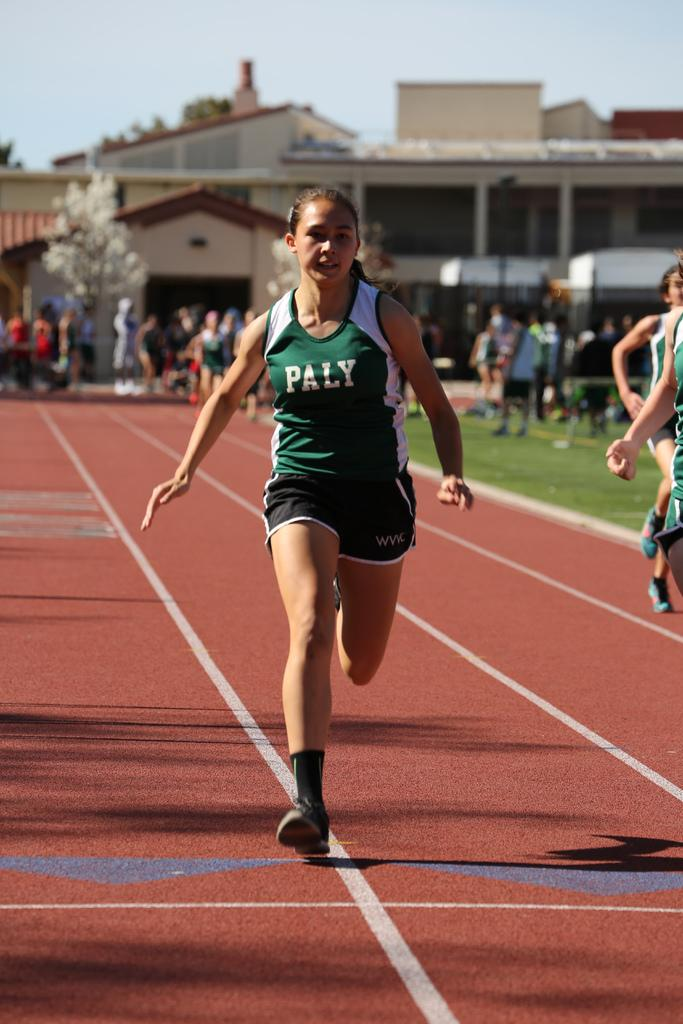What are the persons in the image doing? There are persons running on the ground and standing in the image. What type of terrain is visible in the image? There is grass visible in the image. What other natural elements can be seen in the image? There are trees in the image. What type of structure is present in the image? There is a building in the image. What is visible at the top of the image? The sky is visible at the top of the image. What type of religion is being practiced by the persons in the image? There is no indication of any religious practice in the image; the persons are running and standing, and there are no religious symbols or activities depicted. 